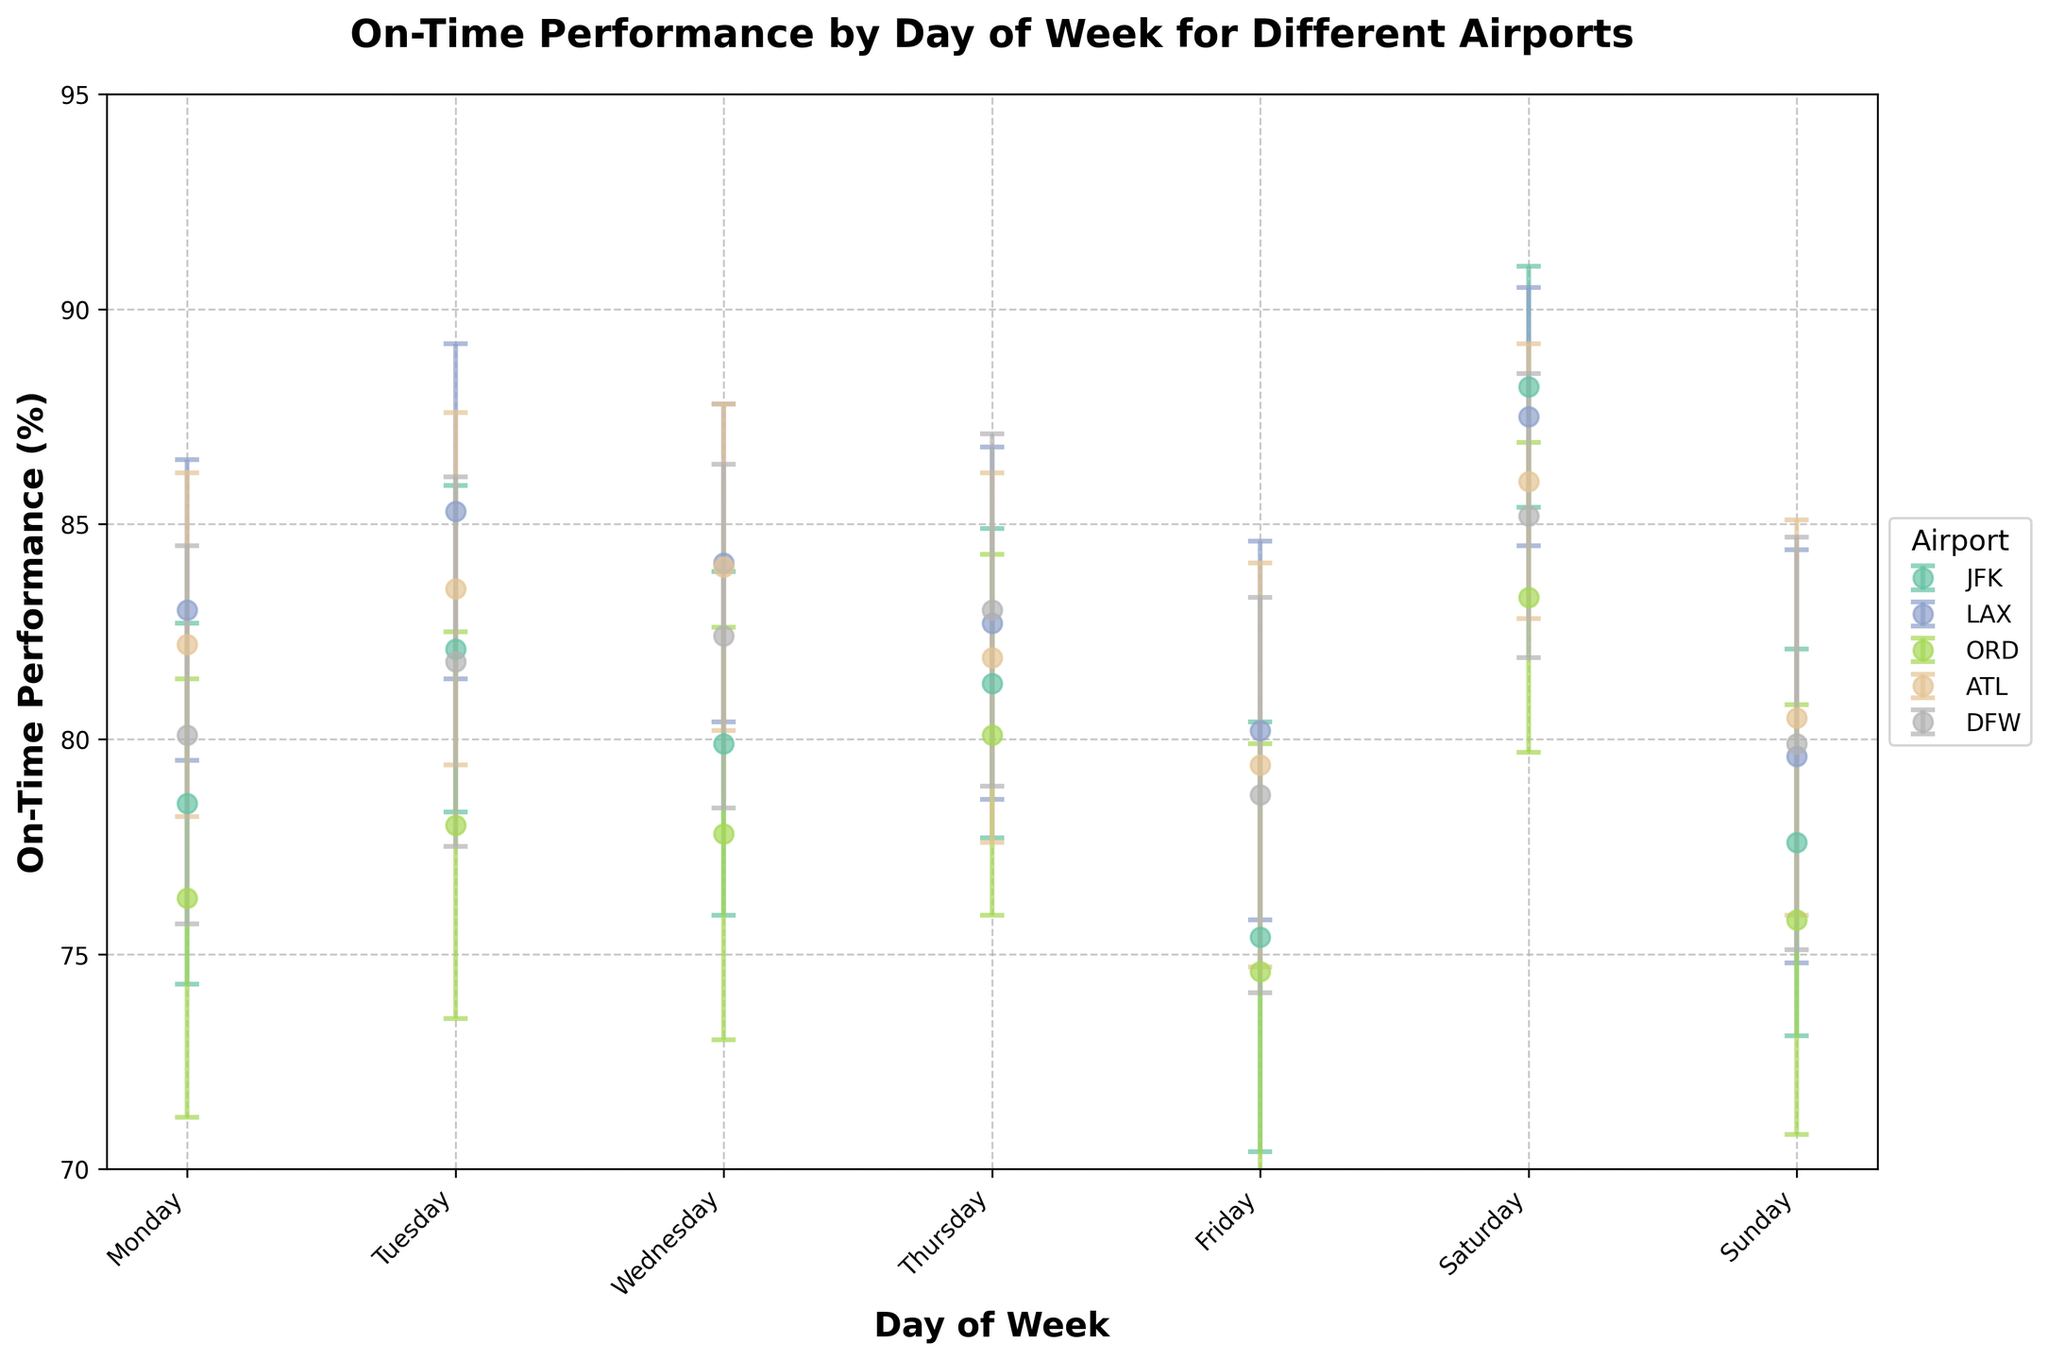What is the lowest on-time performance on a Friday and at which airport? The lowest on-time performance on a Friday can be found by looking at the data points for all airports on this day. JFK has a value of 75.4% and ORD has a value of 74.6%.
Answer: 74.6%, ORD Which day does ATL airport have the highest on-time performance? The highest on-time performance for ATL airport can be found by observing the data points across all days. This occurs on Saturday with a value of 86.0%.
Answer: Saturday How does JFK’s on-time performance on Sunday compare with LAX’s performance on the same day? By comparing the data points for JFK and LAX on Sunday: JFK's Sunday value is 77.6% and LAX's is 79.6%. Therefore, LAX's performance is higher.
Answer: LAX's performance is higher What is the average on-time performance for DFW airport over the week? To find the average, sum up all on-time performance values for DFW (80.1, 81.8, 82.4, 83.0, 78.7, 85.2, 79.9) and divide by the number of days (7): (80.1 + 81.8 + 82.4 + 83.0 + 78.7 + 85.2 + 79.9) / 7 = 81.6%.
Answer: 81.6% Which airport exhibits the greatest variability in on-time performance over the week? Variability can be inferred from the error margins. By examining the error bars, ORD has the largest ranges, suggesting it has the greatest variability.
Answer: ORD On which day does JFK airport have the largest error margin in its on-time performance? The error margins for JFK across all days need to be compared. The largest margin is 5.0% which occurs on Friday.
Answer: Friday Compare the on-time performance on Saturday between all airports, and rank them from highest to lowest. On Saturday, the on-time performance values are: JFK (88.2%), LAX (87.5%), ORD (83.3%), ATL (86.0%), DFW (85.2%). Ranking from highest to lowest: JFK, LAX, ATL, DFW, ORD.
Answer: JFK > LAX > ATL > DFW > ORD What is the difference in on-time performance between the best and worst day for LAX airport? The best day is Tuesday (85.3%) and the worst day is Sunday (79.6%). The difference is 85.3% - 79.6% = 5.7%.
Answer: 5.7% Considering the error margins, on which day is the on-time performance for ORD least precise? Preciseness is inversely related to error margin. The largest error margin for ORD is on Friday with 5.3%.
Answer: Friday If you had to pick one day of the week where all airports have relatively good on-time performance, which day would it be and why? Saturday shows relatively high on-time performance for all airports: JFK (88.2%), LAX (87.5%), ORD (83.3%), ATL (86.0%), DFW (85.2%). These are higher than the typical daily figures for each airport.
Answer: Saturday 